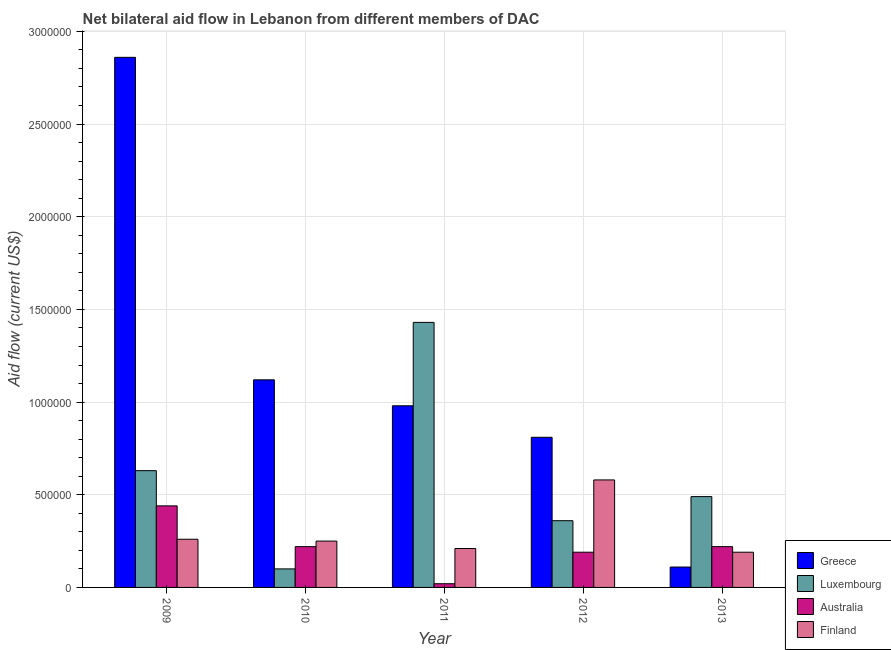How many different coloured bars are there?
Your answer should be compact. 4. How many groups of bars are there?
Your response must be concise. 5. Are the number of bars per tick equal to the number of legend labels?
Keep it short and to the point. Yes. Are the number of bars on each tick of the X-axis equal?
Provide a succinct answer. Yes. How many bars are there on the 4th tick from the left?
Provide a succinct answer. 4. In how many cases, is the number of bars for a given year not equal to the number of legend labels?
Your response must be concise. 0. What is the amount of aid given by luxembourg in 2011?
Offer a terse response. 1.43e+06. Across all years, what is the maximum amount of aid given by luxembourg?
Give a very brief answer. 1.43e+06. Across all years, what is the minimum amount of aid given by australia?
Ensure brevity in your answer.  2.00e+04. In which year was the amount of aid given by greece minimum?
Ensure brevity in your answer.  2013. What is the total amount of aid given by luxembourg in the graph?
Offer a very short reply. 3.01e+06. What is the difference between the amount of aid given by finland in 2009 and that in 2013?
Keep it short and to the point. 7.00e+04. What is the difference between the amount of aid given by australia in 2013 and the amount of aid given by luxembourg in 2011?
Offer a terse response. 2.00e+05. What is the average amount of aid given by finland per year?
Your answer should be very brief. 2.98e+05. In the year 2011, what is the difference between the amount of aid given by finland and amount of aid given by australia?
Provide a succinct answer. 0. In how many years, is the amount of aid given by australia greater than 700000 US$?
Your answer should be very brief. 0. What is the ratio of the amount of aid given by luxembourg in 2011 to that in 2012?
Keep it short and to the point. 3.97. Is the amount of aid given by luxembourg in 2010 less than that in 2013?
Your answer should be very brief. Yes. Is the difference between the amount of aid given by luxembourg in 2009 and 2013 greater than the difference between the amount of aid given by finland in 2009 and 2013?
Ensure brevity in your answer.  No. What is the difference between the highest and the lowest amount of aid given by luxembourg?
Make the answer very short. 1.33e+06. In how many years, is the amount of aid given by australia greater than the average amount of aid given by australia taken over all years?
Your answer should be compact. 3. Is the sum of the amount of aid given by australia in 2010 and 2013 greater than the maximum amount of aid given by greece across all years?
Give a very brief answer. No. What does the 3rd bar from the right in 2009 represents?
Offer a very short reply. Luxembourg. How many bars are there?
Ensure brevity in your answer.  20. Are all the bars in the graph horizontal?
Your answer should be very brief. No. Are the values on the major ticks of Y-axis written in scientific E-notation?
Make the answer very short. No. Does the graph contain any zero values?
Ensure brevity in your answer.  No. Does the graph contain grids?
Offer a terse response. Yes. Where does the legend appear in the graph?
Make the answer very short. Bottom right. How many legend labels are there?
Ensure brevity in your answer.  4. How are the legend labels stacked?
Your response must be concise. Vertical. What is the title of the graph?
Ensure brevity in your answer.  Net bilateral aid flow in Lebanon from different members of DAC. Does "Other greenhouse gases" appear as one of the legend labels in the graph?
Keep it short and to the point. No. What is the label or title of the X-axis?
Your answer should be very brief. Year. What is the label or title of the Y-axis?
Provide a short and direct response. Aid flow (current US$). What is the Aid flow (current US$) in Greece in 2009?
Give a very brief answer. 2.86e+06. What is the Aid flow (current US$) in Luxembourg in 2009?
Offer a terse response. 6.30e+05. What is the Aid flow (current US$) of Australia in 2009?
Offer a terse response. 4.40e+05. What is the Aid flow (current US$) in Finland in 2009?
Make the answer very short. 2.60e+05. What is the Aid flow (current US$) of Greece in 2010?
Keep it short and to the point. 1.12e+06. What is the Aid flow (current US$) of Australia in 2010?
Provide a succinct answer. 2.20e+05. What is the Aid flow (current US$) in Finland in 2010?
Your answer should be very brief. 2.50e+05. What is the Aid flow (current US$) of Greece in 2011?
Your answer should be compact. 9.80e+05. What is the Aid flow (current US$) of Luxembourg in 2011?
Your response must be concise. 1.43e+06. What is the Aid flow (current US$) of Australia in 2011?
Give a very brief answer. 2.00e+04. What is the Aid flow (current US$) of Greece in 2012?
Make the answer very short. 8.10e+05. What is the Aid flow (current US$) in Finland in 2012?
Offer a terse response. 5.80e+05. Across all years, what is the maximum Aid flow (current US$) of Greece?
Offer a very short reply. 2.86e+06. Across all years, what is the maximum Aid flow (current US$) of Luxembourg?
Your answer should be compact. 1.43e+06. Across all years, what is the maximum Aid flow (current US$) of Australia?
Provide a succinct answer. 4.40e+05. Across all years, what is the maximum Aid flow (current US$) of Finland?
Make the answer very short. 5.80e+05. Across all years, what is the minimum Aid flow (current US$) in Greece?
Your answer should be very brief. 1.10e+05. Across all years, what is the minimum Aid flow (current US$) in Australia?
Keep it short and to the point. 2.00e+04. Across all years, what is the minimum Aid flow (current US$) in Finland?
Provide a succinct answer. 1.90e+05. What is the total Aid flow (current US$) in Greece in the graph?
Your answer should be very brief. 5.88e+06. What is the total Aid flow (current US$) in Luxembourg in the graph?
Your answer should be compact. 3.01e+06. What is the total Aid flow (current US$) in Australia in the graph?
Your answer should be very brief. 1.09e+06. What is the total Aid flow (current US$) of Finland in the graph?
Make the answer very short. 1.49e+06. What is the difference between the Aid flow (current US$) in Greece in 2009 and that in 2010?
Provide a short and direct response. 1.74e+06. What is the difference between the Aid flow (current US$) in Luxembourg in 2009 and that in 2010?
Make the answer very short. 5.30e+05. What is the difference between the Aid flow (current US$) in Australia in 2009 and that in 2010?
Give a very brief answer. 2.20e+05. What is the difference between the Aid flow (current US$) in Greece in 2009 and that in 2011?
Offer a terse response. 1.88e+06. What is the difference between the Aid flow (current US$) of Luxembourg in 2009 and that in 2011?
Your response must be concise. -8.00e+05. What is the difference between the Aid flow (current US$) in Finland in 2009 and that in 2011?
Make the answer very short. 5.00e+04. What is the difference between the Aid flow (current US$) in Greece in 2009 and that in 2012?
Make the answer very short. 2.05e+06. What is the difference between the Aid flow (current US$) of Luxembourg in 2009 and that in 2012?
Ensure brevity in your answer.  2.70e+05. What is the difference between the Aid flow (current US$) in Finland in 2009 and that in 2012?
Make the answer very short. -3.20e+05. What is the difference between the Aid flow (current US$) in Greece in 2009 and that in 2013?
Give a very brief answer. 2.75e+06. What is the difference between the Aid flow (current US$) in Luxembourg in 2009 and that in 2013?
Give a very brief answer. 1.40e+05. What is the difference between the Aid flow (current US$) of Luxembourg in 2010 and that in 2011?
Keep it short and to the point. -1.33e+06. What is the difference between the Aid flow (current US$) in Finland in 2010 and that in 2011?
Provide a succinct answer. 4.00e+04. What is the difference between the Aid flow (current US$) in Australia in 2010 and that in 2012?
Your answer should be compact. 3.00e+04. What is the difference between the Aid flow (current US$) of Finland in 2010 and that in 2012?
Keep it short and to the point. -3.30e+05. What is the difference between the Aid flow (current US$) of Greece in 2010 and that in 2013?
Give a very brief answer. 1.01e+06. What is the difference between the Aid flow (current US$) in Luxembourg in 2010 and that in 2013?
Your response must be concise. -3.90e+05. What is the difference between the Aid flow (current US$) in Luxembourg in 2011 and that in 2012?
Your answer should be compact. 1.07e+06. What is the difference between the Aid flow (current US$) in Finland in 2011 and that in 2012?
Give a very brief answer. -3.70e+05. What is the difference between the Aid flow (current US$) of Greece in 2011 and that in 2013?
Make the answer very short. 8.70e+05. What is the difference between the Aid flow (current US$) of Luxembourg in 2011 and that in 2013?
Keep it short and to the point. 9.40e+05. What is the difference between the Aid flow (current US$) of Australia in 2011 and that in 2013?
Make the answer very short. -2.00e+05. What is the difference between the Aid flow (current US$) in Finland in 2011 and that in 2013?
Your response must be concise. 2.00e+04. What is the difference between the Aid flow (current US$) in Greece in 2009 and the Aid flow (current US$) in Luxembourg in 2010?
Provide a succinct answer. 2.76e+06. What is the difference between the Aid flow (current US$) of Greece in 2009 and the Aid flow (current US$) of Australia in 2010?
Make the answer very short. 2.64e+06. What is the difference between the Aid flow (current US$) of Greece in 2009 and the Aid flow (current US$) of Finland in 2010?
Offer a terse response. 2.61e+06. What is the difference between the Aid flow (current US$) in Luxembourg in 2009 and the Aid flow (current US$) in Finland in 2010?
Your answer should be compact. 3.80e+05. What is the difference between the Aid flow (current US$) in Greece in 2009 and the Aid flow (current US$) in Luxembourg in 2011?
Ensure brevity in your answer.  1.43e+06. What is the difference between the Aid flow (current US$) of Greece in 2009 and the Aid flow (current US$) of Australia in 2011?
Offer a very short reply. 2.84e+06. What is the difference between the Aid flow (current US$) of Greece in 2009 and the Aid flow (current US$) of Finland in 2011?
Your answer should be very brief. 2.65e+06. What is the difference between the Aid flow (current US$) of Luxembourg in 2009 and the Aid flow (current US$) of Finland in 2011?
Your answer should be very brief. 4.20e+05. What is the difference between the Aid flow (current US$) in Greece in 2009 and the Aid flow (current US$) in Luxembourg in 2012?
Provide a succinct answer. 2.50e+06. What is the difference between the Aid flow (current US$) in Greece in 2009 and the Aid flow (current US$) in Australia in 2012?
Your answer should be very brief. 2.67e+06. What is the difference between the Aid flow (current US$) in Greece in 2009 and the Aid flow (current US$) in Finland in 2012?
Make the answer very short. 2.28e+06. What is the difference between the Aid flow (current US$) in Greece in 2009 and the Aid flow (current US$) in Luxembourg in 2013?
Make the answer very short. 2.37e+06. What is the difference between the Aid flow (current US$) in Greece in 2009 and the Aid flow (current US$) in Australia in 2013?
Give a very brief answer. 2.64e+06. What is the difference between the Aid flow (current US$) of Greece in 2009 and the Aid flow (current US$) of Finland in 2013?
Provide a short and direct response. 2.67e+06. What is the difference between the Aid flow (current US$) in Greece in 2010 and the Aid flow (current US$) in Luxembourg in 2011?
Your answer should be compact. -3.10e+05. What is the difference between the Aid flow (current US$) in Greece in 2010 and the Aid flow (current US$) in Australia in 2011?
Your answer should be compact. 1.10e+06. What is the difference between the Aid flow (current US$) in Greece in 2010 and the Aid flow (current US$) in Finland in 2011?
Give a very brief answer. 9.10e+05. What is the difference between the Aid flow (current US$) of Luxembourg in 2010 and the Aid flow (current US$) of Finland in 2011?
Keep it short and to the point. -1.10e+05. What is the difference between the Aid flow (current US$) in Australia in 2010 and the Aid flow (current US$) in Finland in 2011?
Offer a terse response. 10000. What is the difference between the Aid flow (current US$) of Greece in 2010 and the Aid flow (current US$) of Luxembourg in 2012?
Keep it short and to the point. 7.60e+05. What is the difference between the Aid flow (current US$) of Greece in 2010 and the Aid flow (current US$) of Australia in 2012?
Your response must be concise. 9.30e+05. What is the difference between the Aid flow (current US$) in Greece in 2010 and the Aid flow (current US$) in Finland in 2012?
Provide a succinct answer. 5.40e+05. What is the difference between the Aid flow (current US$) in Luxembourg in 2010 and the Aid flow (current US$) in Australia in 2012?
Your answer should be very brief. -9.00e+04. What is the difference between the Aid flow (current US$) in Luxembourg in 2010 and the Aid flow (current US$) in Finland in 2012?
Your response must be concise. -4.80e+05. What is the difference between the Aid flow (current US$) in Australia in 2010 and the Aid flow (current US$) in Finland in 2012?
Offer a terse response. -3.60e+05. What is the difference between the Aid flow (current US$) of Greece in 2010 and the Aid flow (current US$) of Luxembourg in 2013?
Keep it short and to the point. 6.30e+05. What is the difference between the Aid flow (current US$) of Greece in 2010 and the Aid flow (current US$) of Australia in 2013?
Ensure brevity in your answer.  9.00e+05. What is the difference between the Aid flow (current US$) in Greece in 2010 and the Aid flow (current US$) in Finland in 2013?
Your response must be concise. 9.30e+05. What is the difference between the Aid flow (current US$) of Luxembourg in 2010 and the Aid flow (current US$) of Finland in 2013?
Keep it short and to the point. -9.00e+04. What is the difference between the Aid flow (current US$) of Australia in 2010 and the Aid flow (current US$) of Finland in 2013?
Keep it short and to the point. 3.00e+04. What is the difference between the Aid flow (current US$) in Greece in 2011 and the Aid flow (current US$) in Luxembourg in 2012?
Keep it short and to the point. 6.20e+05. What is the difference between the Aid flow (current US$) in Greece in 2011 and the Aid flow (current US$) in Australia in 2012?
Your answer should be compact. 7.90e+05. What is the difference between the Aid flow (current US$) in Greece in 2011 and the Aid flow (current US$) in Finland in 2012?
Keep it short and to the point. 4.00e+05. What is the difference between the Aid flow (current US$) in Luxembourg in 2011 and the Aid flow (current US$) in Australia in 2012?
Your answer should be very brief. 1.24e+06. What is the difference between the Aid flow (current US$) of Luxembourg in 2011 and the Aid flow (current US$) of Finland in 2012?
Provide a succinct answer. 8.50e+05. What is the difference between the Aid flow (current US$) in Australia in 2011 and the Aid flow (current US$) in Finland in 2012?
Your answer should be compact. -5.60e+05. What is the difference between the Aid flow (current US$) of Greece in 2011 and the Aid flow (current US$) of Australia in 2013?
Offer a terse response. 7.60e+05. What is the difference between the Aid flow (current US$) of Greece in 2011 and the Aid flow (current US$) of Finland in 2013?
Provide a succinct answer. 7.90e+05. What is the difference between the Aid flow (current US$) of Luxembourg in 2011 and the Aid flow (current US$) of Australia in 2013?
Ensure brevity in your answer.  1.21e+06. What is the difference between the Aid flow (current US$) of Luxembourg in 2011 and the Aid flow (current US$) of Finland in 2013?
Your answer should be compact. 1.24e+06. What is the difference between the Aid flow (current US$) in Australia in 2011 and the Aid flow (current US$) in Finland in 2013?
Your answer should be compact. -1.70e+05. What is the difference between the Aid flow (current US$) of Greece in 2012 and the Aid flow (current US$) of Australia in 2013?
Offer a very short reply. 5.90e+05. What is the difference between the Aid flow (current US$) in Greece in 2012 and the Aid flow (current US$) in Finland in 2013?
Keep it short and to the point. 6.20e+05. What is the difference between the Aid flow (current US$) of Luxembourg in 2012 and the Aid flow (current US$) of Australia in 2013?
Keep it short and to the point. 1.40e+05. What is the average Aid flow (current US$) of Greece per year?
Offer a very short reply. 1.18e+06. What is the average Aid flow (current US$) of Luxembourg per year?
Offer a terse response. 6.02e+05. What is the average Aid flow (current US$) of Australia per year?
Make the answer very short. 2.18e+05. What is the average Aid flow (current US$) in Finland per year?
Your answer should be compact. 2.98e+05. In the year 2009, what is the difference between the Aid flow (current US$) in Greece and Aid flow (current US$) in Luxembourg?
Offer a terse response. 2.23e+06. In the year 2009, what is the difference between the Aid flow (current US$) of Greece and Aid flow (current US$) of Australia?
Your answer should be compact. 2.42e+06. In the year 2009, what is the difference between the Aid flow (current US$) of Greece and Aid flow (current US$) of Finland?
Provide a succinct answer. 2.60e+06. In the year 2009, what is the difference between the Aid flow (current US$) in Australia and Aid flow (current US$) in Finland?
Give a very brief answer. 1.80e+05. In the year 2010, what is the difference between the Aid flow (current US$) of Greece and Aid flow (current US$) of Luxembourg?
Ensure brevity in your answer.  1.02e+06. In the year 2010, what is the difference between the Aid flow (current US$) in Greece and Aid flow (current US$) in Australia?
Ensure brevity in your answer.  9.00e+05. In the year 2010, what is the difference between the Aid flow (current US$) in Greece and Aid flow (current US$) in Finland?
Your answer should be very brief. 8.70e+05. In the year 2010, what is the difference between the Aid flow (current US$) of Australia and Aid flow (current US$) of Finland?
Make the answer very short. -3.00e+04. In the year 2011, what is the difference between the Aid flow (current US$) in Greece and Aid flow (current US$) in Luxembourg?
Give a very brief answer. -4.50e+05. In the year 2011, what is the difference between the Aid flow (current US$) of Greece and Aid flow (current US$) of Australia?
Give a very brief answer. 9.60e+05. In the year 2011, what is the difference between the Aid flow (current US$) in Greece and Aid flow (current US$) in Finland?
Offer a very short reply. 7.70e+05. In the year 2011, what is the difference between the Aid flow (current US$) of Luxembourg and Aid flow (current US$) of Australia?
Give a very brief answer. 1.41e+06. In the year 2011, what is the difference between the Aid flow (current US$) of Luxembourg and Aid flow (current US$) of Finland?
Your answer should be compact. 1.22e+06. In the year 2011, what is the difference between the Aid flow (current US$) in Australia and Aid flow (current US$) in Finland?
Give a very brief answer. -1.90e+05. In the year 2012, what is the difference between the Aid flow (current US$) in Greece and Aid flow (current US$) in Luxembourg?
Ensure brevity in your answer.  4.50e+05. In the year 2012, what is the difference between the Aid flow (current US$) in Greece and Aid flow (current US$) in Australia?
Offer a very short reply. 6.20e+05. In the year 2012, what is the difference between the Aid flow (current US$) in Greece and Aid flow (current US$) in Finland?
Ensure brevity in your answer.  2.30e+05. In the year 2012, what is the difference between the Aid flow (current US$) of Australia and Aid flow (current US$) of Finland?
Give a very brief answer. -3.90e+05. In the year 2013, what is the difference between the Aid flow (current US$) of Greece and Aid flow (current US$) of Luxembourg?
Keep it short and to the point. -3.80e+05. In the year 2013, what is the difference between the Aid flow (current US$) of Greece and Aid flow (current US$) of Australia?
Provide a succinct answer. -1.10e+05. In the year 2013, what is the difference between the Aid flow (current US$) in Greece and Aid flow (current US$) in Finland?
Your response must be concise. -8.00e+04. In the year 2013, what is the difference between the Aid flow (current US$) in Luxembourg and Aid flow (current US$) in Australia?
Ensure brevity in your answer.  2.70e+05. What is the ratio of the Aid flow (current US$) in Greece in 2009 to that in 2010?
Ensure brevity in your answer.  2.55. What is the ratio of the Aid flow (current US$) of Australia in 2009 to that in 2010?
Your answer should be compact. 2. What is the ratio of the Aid flow (current US$) in Greece in 2009 to that in 2011?
Your response must be concise. 2.92. What is the ratio of the Aid flow (current US$) in Luxembourg in 2009 to that in 2011?
Your answer should be compact. 0.44. What is the ratio of the Aid flow (current US$) in Australia in 2009 to that in 2011?
Give a very brief answer. 22. What is the ratio of the Aid flow (current US$) of Finland in 2009 to that in 2011?
Your answer should be very brief. 1.24. What is the ratio of the Aid flow (current US$) in Greece in 2009 to that in 2012?
Make the answer very short. 3.53. What is the ratio of the Aid flow (current US$) in Australia in 2009 to that in 2012?
Your answer should be compact. 2.32. What is the ratio of the Aid flow (current US$) in Finland in 2009 to that in 2012?
Offer a very short reply. 0.45. What is the ratio of the Aid flow (current US$) of Greece in 2009 to that in 2013?
Give a very brief answer. 26. What is the ratio of the Aid flow (current US$) in Australia in 2009 to that in 2013?
Give a very brief answer. 2. What is the ratio of the Aid flow (current US$) in Finland in 2009 to that in 2013?
Ensure brevity in your answer.  1.37. What is the ratio of the Aid flow (current US$) of Greece in 2010 to that in 2011?
Make the answer very short. 1.14. What is the ratio of the Aid flow (current US$) in Luxembourg in 2010 to that in 2011?
Your response must be concise. 0.07. What is the ratio of the Aid flow (current US$) in Finland in 2010 to that in 2011?
Provide a short and direct response. 1.19. What is the ratio of the Aid flow (current US$) of Greece in 2010 to that in 2012?
Ensure brevity in your answer.  1.38. What is the ratio of the Aid flow (current US$) in Luxembourg in 2010 to that in 2012?
Make the answer very short. 0.28. What is the ratio of the Aid flow (current US$) in Australia in 2010 to that in 2012?
Keep it short and to the point. 1.16. What is the ratio of the Aid flow (current US$) of Finland in 2010 to that in 2012?
Provide a succinct answer. 0.43. What is the ratio of the Aid flow (current US$) in Greece in 2010 to that in 2013?
Keep it short and to the point. 10.18. What is the ratio of the Aid flow (current US$) of Luxembourg in 2010 to that in 2013?
Your response must be concise. 0.2. What is the ratio of the Aid flow (current US$) in Finland in 2010 to that in 2013?
Provide a short and direct response. 1.32. What is the ratio of the Aid flow (current US$) in Greece in 2011 to that in 2012?
Offer a terse response. 1.21. What is the ratio of the Aid flow (current US$) in Luxembourg in 2011 to that in 2012?
Provide a short and direct response. 3.97. What is the ratio of the Aid flow (current US$) in Australia in 2011 to that in 2012?
Provide a succinct answer. 0.11. What is the ratio of the Aid flow (current US$) in Finland in 2011 to that in 2012?
Offer a very short reply. 0.36. What is the ratio of the Aid flow (current US$) in Greece in 2011 to that in 2013?
Give a very brief answer. 8.91. What is the ratio of the Aid flow (current US$) of Luxembourg in 2011 to that in 2013?
Provide a short and direct response. 2.92. What is the ratio of the Aid flow (current US$) in Australia in 2011 to that in 2013?
Offer a very short reply. 0.09. What is the ratio of the Aid flow (current US$) of Finland in 2011 to that in 2013?
Provide a succinct answer. 1.11. What is the ratio of the Aid flow (current US$) in Greece in 2012 to that in 2013?
Make the answer very short. 7.36. What is the ratio of the Aid flow (current US$) of Luxembourg in 2012 to that in 2013?
Keep it short and to the point. 0.73. What is the ratio of the Aid flow (current US$) of Australia in 2012 to that in 2013?
Offer a terse response. 0.86. What is the ratio of the Aid flow (current US$) of Finland in 2012 to that in 2013?
Keep it short and to the point. 3.05. What is the difference between the highest and the second highest Aid flow (current US$) in Greece?
Give a very brief answer. 1.74e+06. What is the difference between the highest and the second highest Aid flow (current US$) of Luxembourg?
Provide a short and direct response. 8.00e+05. What is the difference between the highest and the lowest Aid flow (current US$) in Greece?
Your response must be concise. 2.75e+06. What is the difference between the highest and the lowest Aid flow (current US$) in Luxembourg?
Your response must be concise. 1.33e+06. What is the difference between the highest and the lowest Aid flow (current US$) of Finland?
Give a very brief answer. 3.90e+05. 